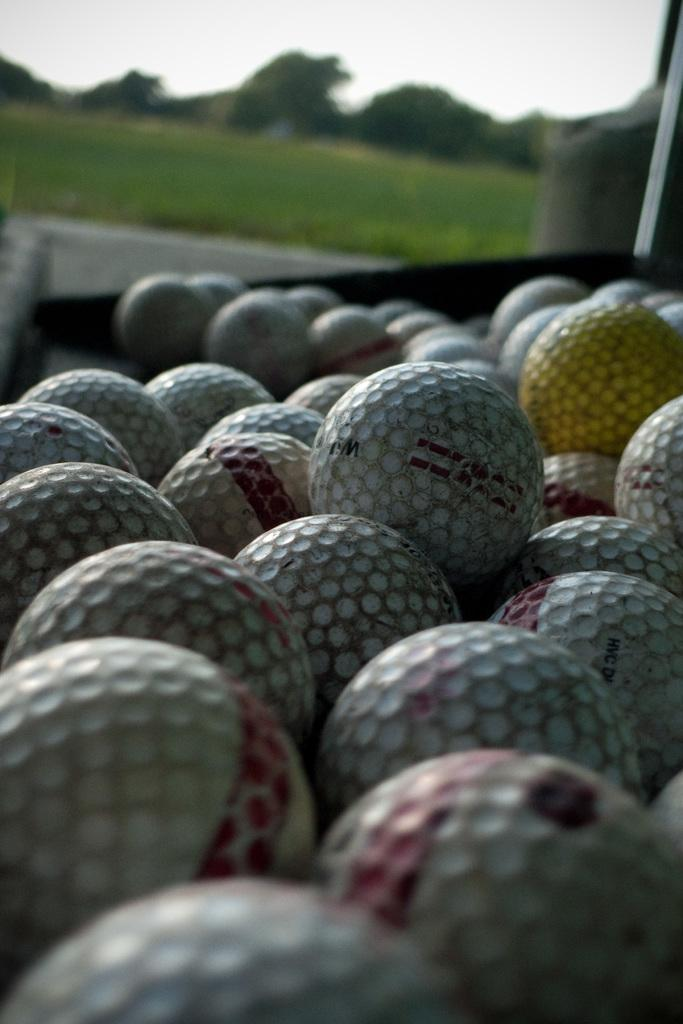What objects are located in the front of the image? There are balls in the front of the image. How would you describe the appearance of the background in the image? The background of the image is blurry. What type of vegetation can be seen in the background of the image? There are trees and grass in the background of the image. What part of the natural environment is visible in the background of the image? The sky is visible in the background of the image. What reason does the mouth have for being in the image? There is no mouth present in the image, so it does not have a reason for being there. 